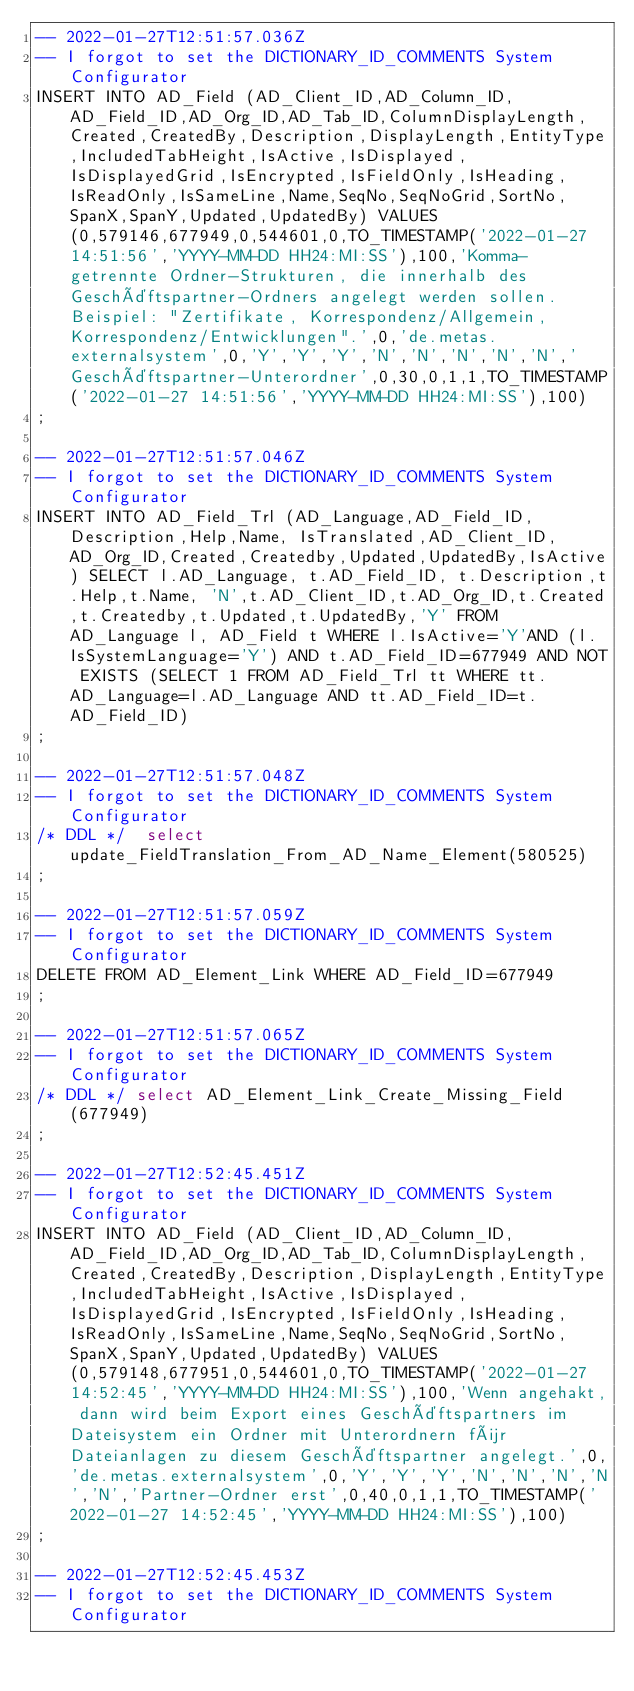Convert code to text. <code><loc_0><loc_0><loc_500><loc_500><_SQL_>-- 2022-01-27T12:51:57.036Z
-- I forgot to set the DICTIONARY_ID_COMMENTS System Configurator
INSERT INTO AD_Field (AD_Client_ID,AD_Column_ID,AD_Field_ID,AD_Org_ID,AD_Tab_ID,ColumnDisplayLength,Created,CreatedBy,Description,DisplayLength,EntityType,IncludedTabHeight,IsActive,IsDisplayed,IsDisplayedGrid,IsEncrypted,IsFieldOnly,IsHeading,IsReadOnly,IsSameLine,Name,SeqNo,SeqNoGrid,SortNo,SpanX,SpanY,Updated,UpdatedBy) VALUES (0,579146,677949,0,544601,0,TO_TIMESTAMP('2022-01-27 14:51:56','YYYY-MM-DD HH24:MI:SS'),100,'Komma-getrennte Ordner-Strukturen, die innerhalb des Geschäftspartner-Ordners angelegt werden sollen. Beispiel: "Zertifikate, Korrespondenz/Allgemein, Korrespondenz/Entwicklungen".',0,'de.metas.externalsystem',0,'Y','Y','Y','N','N','N','N','N','Geschäftspartner-Unterordner',0,30,0,1,1,TO_TIMESTAMP('2022-01-27 14:51:56','YYYY-MM-DD HH24:MI:SS'),100)
;

-- 2022-01-27T12:51:57.046Z
-- I forgot to set the DICTIONARY_ID_COMMENTS System Configurator
INSERT INTO AD_Field_Trl (AD_Language,AD_Field_ID, Description,Help,Name, IsTranslated,AD_Client_ID,AD_Org_ID,Created,Createdby,Updated,UpdatedBy,IsActive) SELECT l.AD_Language, t.AD_Field_ID, t.Description,t.Help,t.Name, 'N',t.AD_Client_ID,t.AD_Org_ID,t.Created,t.Createdby,t.Updated,t.UpdatedBy,'Y' FROM AD_Language l, AD_Field t WHERE l.IsActive='Y'AND (l.IsSystemLanguage='Y') AND t.AD_Field_ID=677949 AND NOT EXISTS (SELECT 1 FROM AD_Field_Trl tt WHERE tt.AD_Language=l.AD_Language AND tt.AD_Field_ID=t.AD_Field_ID)
;

-- 2022-01-27T12:51:57.048Z
-- I forgot to set the DICTIONARY_ID_COMMENTS System Configurator
/* DDL */  select update_FieldTranslation_From_AD_Name_Element(580525) 
;

-- 2022-01-27T12:51:57.059Z
-- I forgot to set the DICTIONARY_ID_COMMENTS System Configurator
DELETE FROM AD_Element_Link WHERE AD_Field_ID=677949
;

-- 2022-01-27T12:51:57.065Z
-- I forgot to set the DICTIONARY_ID_COMMENTS System Configurator
/* DDL */ select AD_Element_Link_Create_Missing_Field(677949)
;

-- 2022-01-27T12:52:45.451Z
-- I forgot to set the DICTIONARY_ID_COMMENTS System Configurator
INSERT INTO AD_Field (AD_Client_ID,AD_Column_ID,AD_Field_ID,AD_Org_ID,AD_Tab_ID,ColumnDisplayLength,Created,CreatedBy,Description,DisplayLength,EntityType,IncludedTabHeight,IsActive,IsDisplayed,IsDisplayedGrid,IsEncrypted,IsFieldOnly,IsHeading,IsReadOnly,IsSameLine,Name,SeqNo,SeqNoGrid,SortNo,SpanX,SpanY,Updated,UpdatedBy) VALUES (0,579148,677951,0,544601,0,TO_TIMESTAMP('2022-01-27 14:52:45','YYYY-MM-DD HH24:MI:SS'),100,'Wenn angehakt, dann wird beim Export eines Geschäftspartners im Dateisystem ein Ordner mit Unterordnern für Dateianlagen zu diesem Geschäftspartner angelegt.',0,'de.metas.externalsystem',0,'Y','Y','Y','N','N','N','N','N','Partner-Ordner erst',0,40,0,1,1,TO_TIMESTAMP('2022-01-27 14:52:45','YYYY-MM-DD HH24:MI:SS'),100)
;

-- 2022-01-27T12:52:45.453Z
-- I forgot to set the DICTIONARY_ID_COMMENTS System Configurator</code> 